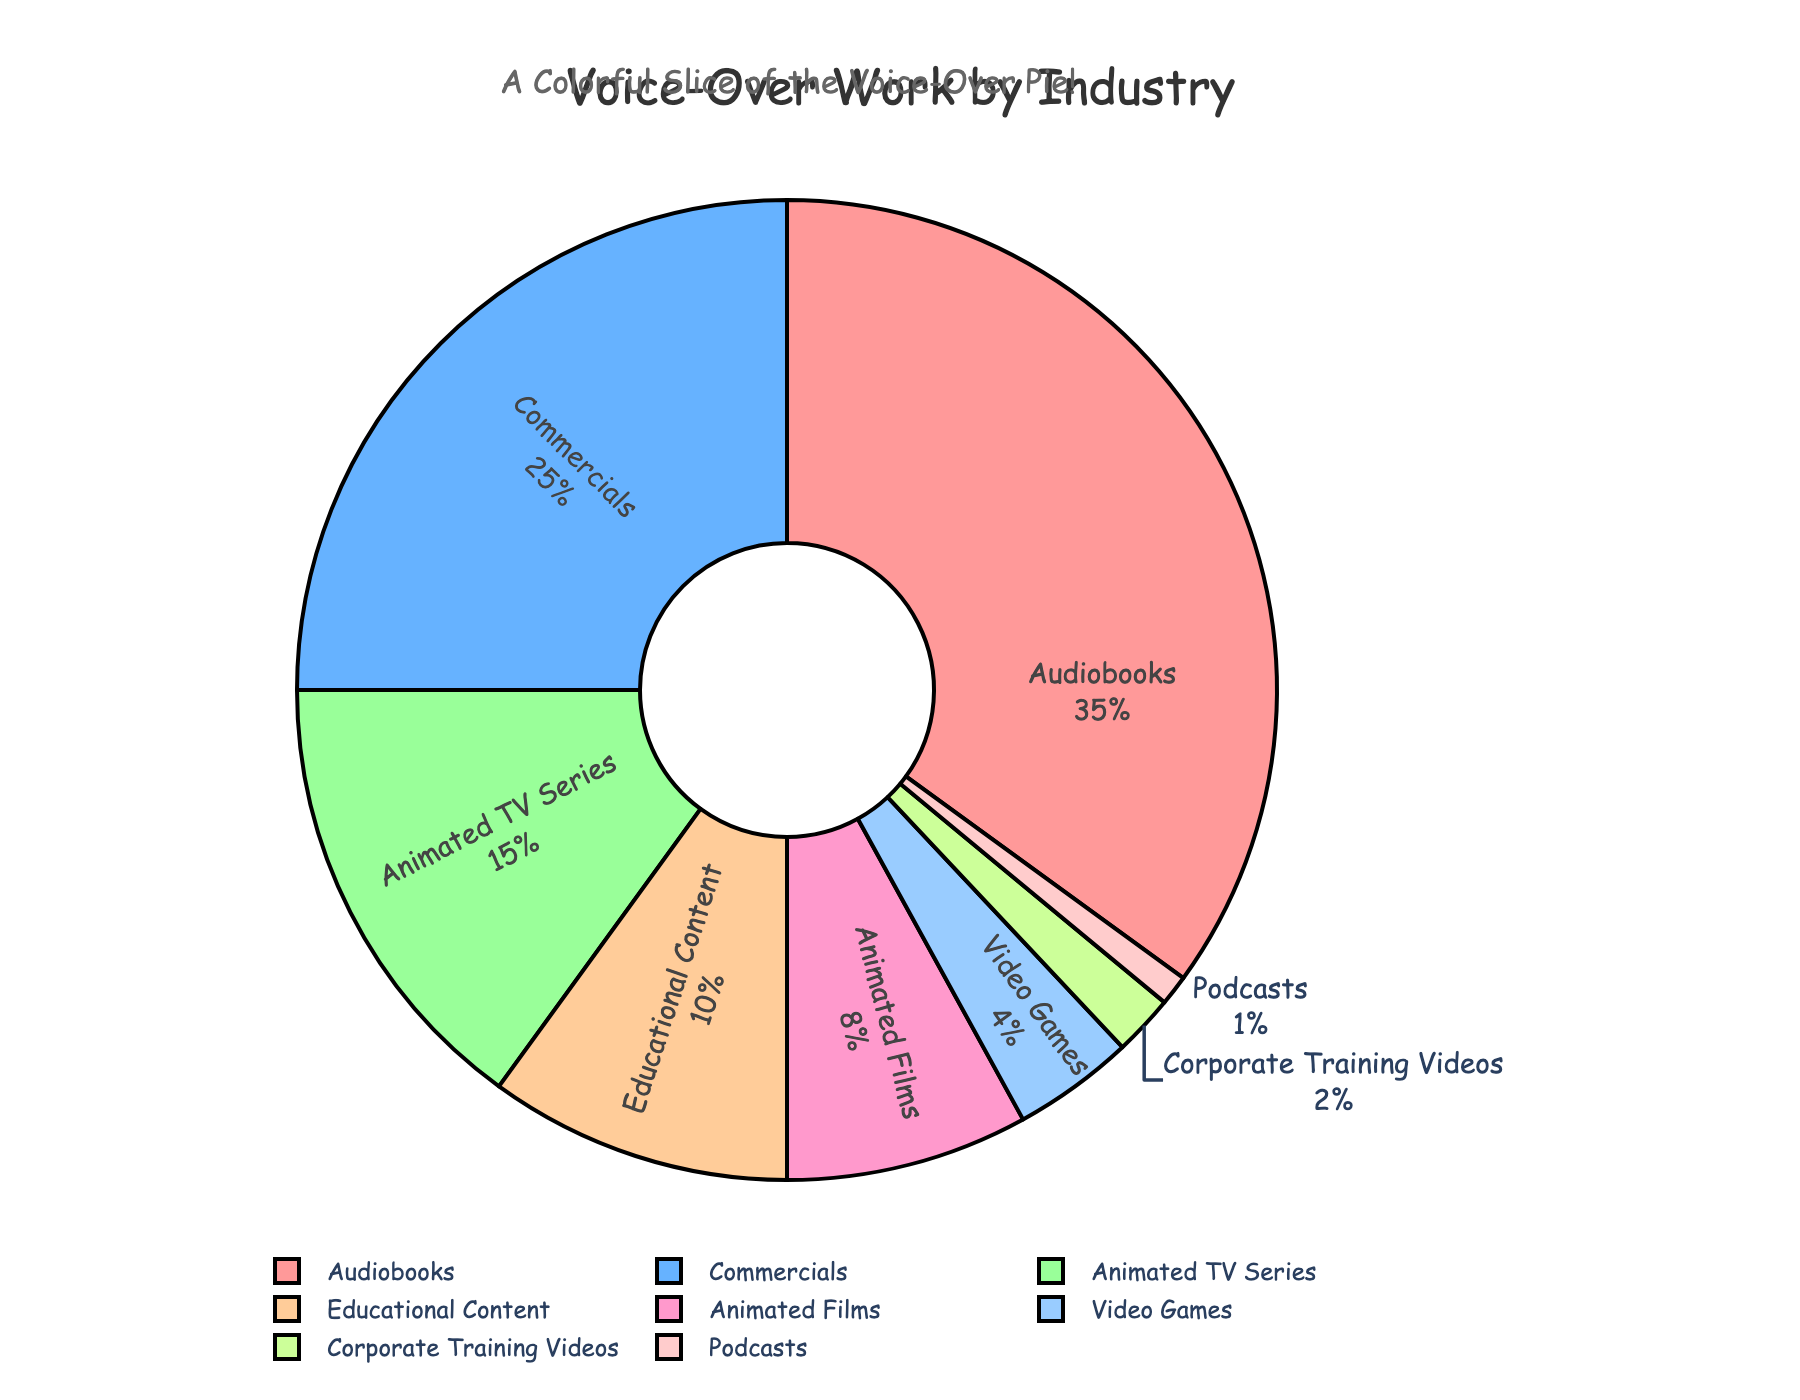What percentage of the pie chart represents animated content (both films and TV series combined)? To find the percentage representing animated content, add the percentages of both Animated Films and Animated TV Series. Animated Films = 8% and Animated TV Series = 15%. Therefore, the combined percentage is 8% + 15% = 23%.
Answer: 23% Which industry holds the largest share in the pie chart? The industry with the largest share is the one with the highest percentage. From the chart, Audiobooks hold 35%, which is the highest percentage.
Answer: Audiobooks What is the difference in percentage between Commercials and Educational Content? Subtract the percentage of Educational Content from the percentage of Commercials. Commercials = 25%, Educational Content = 10%. Therefore, the difference is 25% - 10% = 15%.
Answer: 15% What fraction of the pie chart is taken by Video Games and Podcasts combined? To find the fraction, add the percentages of Video Games and Podcasts and then divide by 100 to convert to fraction form. Video Games = 4%, Podcasts = 1%. Combined, they represent 4% + 1% = 5%. Thus, the fraction is 5/100 = 1/20.
Answer: 1/20 How does the share of Corporate Training Videos compare to the share of Animated Films? Compare the percentages of Corporate Training Videos and Animated Films. Corporate Training Videos = 2%, Animated Films = 8%. Since 2% is less than 8%, Corporate Training Videos have a smaller share.
Answer: Smaller Identify the industry with the smallest share and state its percentage. The industry with the smallest share is the one with the lowest percentage in the chart. From the chart, Podcasts have the smallest share at 1%.
Answer: Podcasts, 1% Which industries have shares greater than 20%? Identify industries with percentages above 20%. From the chart, Audiobooks (35%) and Commercials (25%) have shares greater than 20%.
Answer: Audiobooks, Commercials Excluding Audiobooks and Commercials, what is the average percentage of the remaining industries? First, sum the percentages of the remaining industries: Animated TV Series (15%), Educational Content (10%), Animated Films (8%), Video Games (4%), Corporate Training Videos (2%), Podcasts (1%). The total is 15% + 10% + 8% + 4% + 2% + 1% = 40%. There are 6 industries in this group, so the average is 40% / 6 ≈ 6.67%.
Answer: 6.67% Which color represents the industry with the third-largest share? Identify the industry with the third-largest share, which is Animated TV Series (15%). The color representing Animated TV Series in the chart is the third color listed, light green.
Answer: Light green 